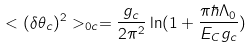Convert formula to latex. <formula><loc_0><loc_0><loc_500><loc_500>< ( \delta \theta _ { c } ) ^ { 2 } > _ { 0 c } = { \frac { g _ { c } } { 2 \pi ^ { 2 } } } \ln ( 1 + { \frac { \pi \hbar { \Lambda } _ { 0 } } { E _ { C } g _ { c } } } )</formula> 